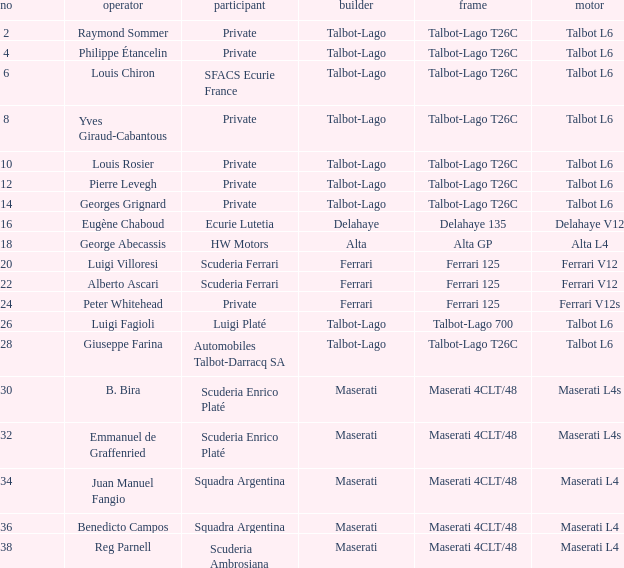Name the chassis for b. bira Maserati 4CLT/48. 